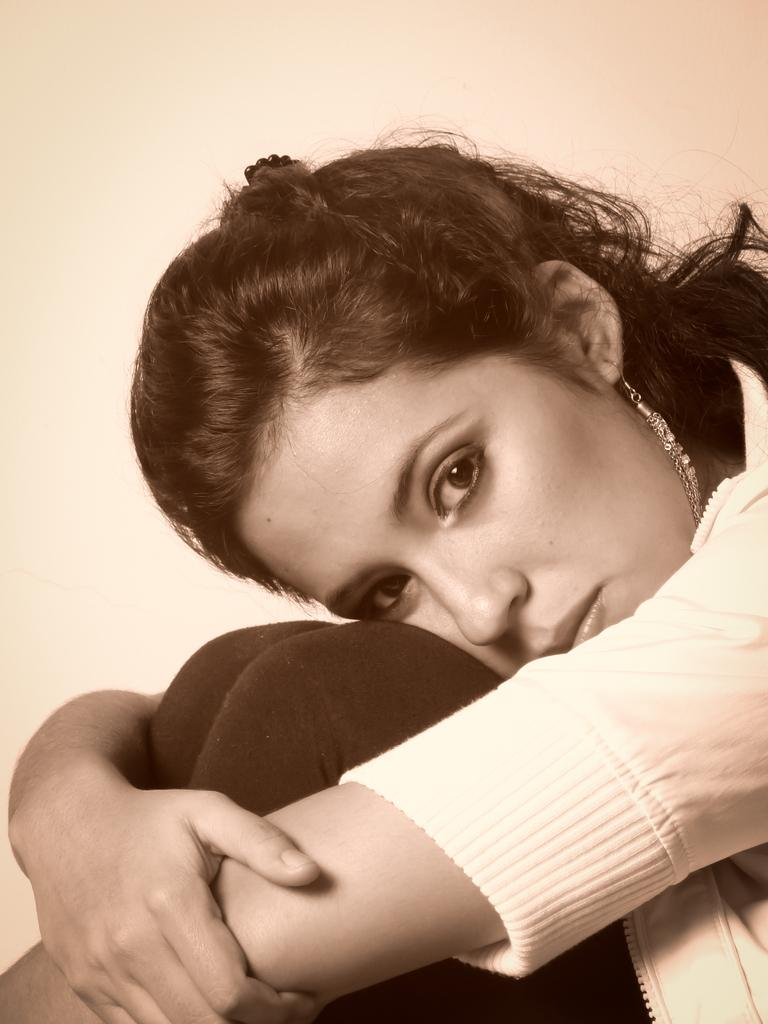What is the woman doing in the image? The woman is sitting in the image. What can be seen in the background of the image? There is a wall in the background of the image. What type of stamp can be seen on the wall in the image? There is no stamp visible on the wall in the image. 